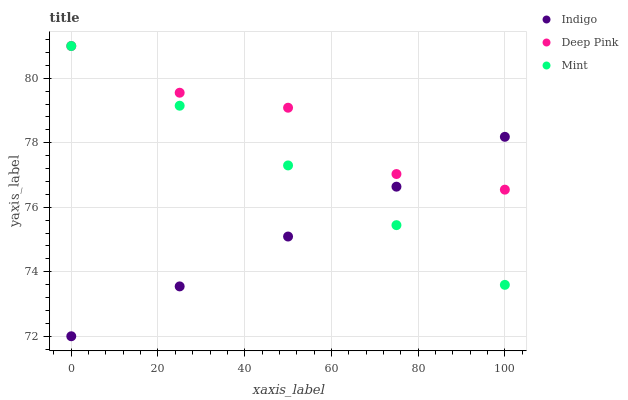Does Indigo have the minimum area under the curve?
Answer yes or no. Yes. Does Deep Pink have the maximum area under the curve?
Answer yes or no. Yes. Does Deep Pink have the minimum area under the curve?
Answer yes or no. No. Does Indigo have the maximum area under the curve?
Answer yes or no. No. Is Mint the smoothest?
Answer yes or no. Yes. Is Deep Pink the roughest?
Answer yes or no. Yes. Is Deep Pink the smoothest?
Answer yes or no. No. Is Indigo the roughest?
Answer yes or no. No. Does Indigo have the lowest value?
Answer yes or no. Yes. Does Deep Pink have the lowest value?
Answer yes or no. No. Does Deep Pink have the highest value?
Answer yes or no. Yes. Does Indigo have the highest value?
Answer yes or no. No. Does Indigo intersect Mint?
Answer yes or no. Yes. Is Indigo less than Mint?
Answer yes or no. No. Is Indigo greater than Mint?
Answer yes or no. No. 